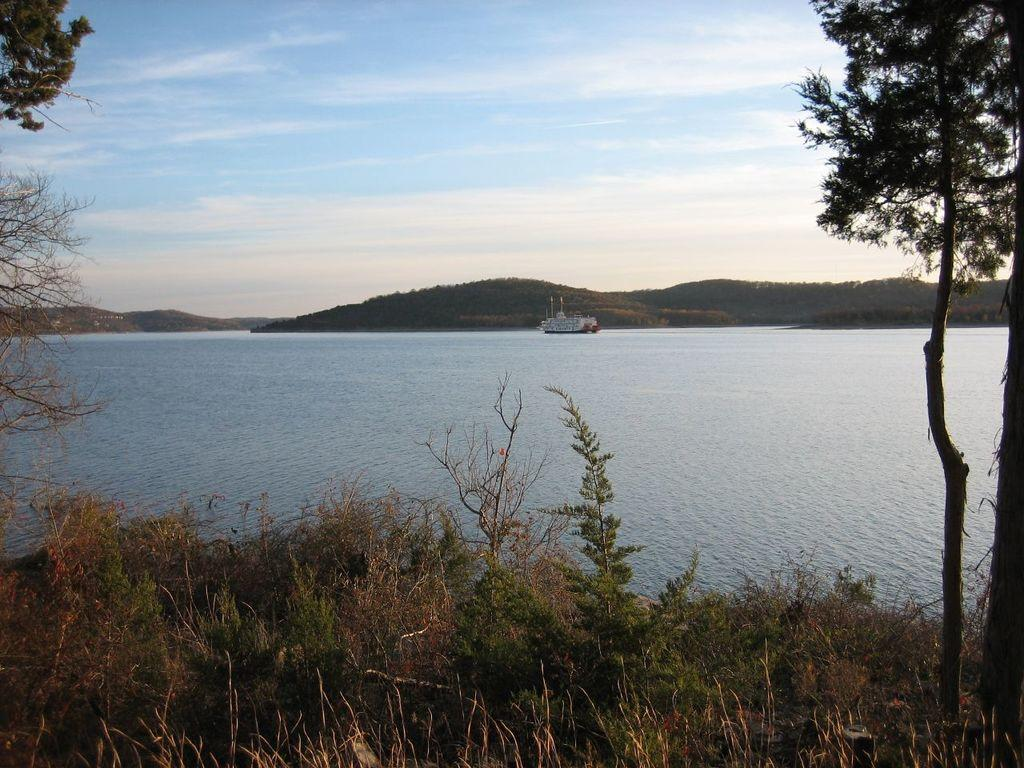What type of natural landform can be seen in the image? There are mountains in the image. What body of water is present in the image? There is a river in the image. What is on the river in the image? There is a boat on the river. What type of vegetation is present in the image? There are trees, bushes, plants, and grass in the image. What part of the natural environment is visible in the image? The sky is visible at the top of the image. What type of song is being played in the background of the image? There is no information about any song being played in the image. What type of business is conducted near the river in the image? There is no information about any business in the image. 